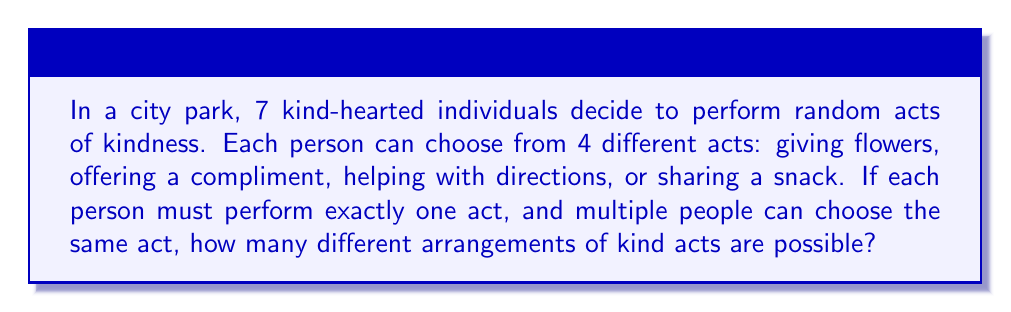Solve this math problem. Let's approach this step-by-step:

1) We have 7 people, each of whom needs to choose 1 act out of 4 possible acts.

2) For each person, there are 4 choices, and their choice is independent of the others.

3) This scenario fits the multiplication principle of counting.

4) According to this principle, if we have a sequence of $n$ independent choices, where the $i$-th choice has $k_i$ options, the total number of possible outcomes is the product of the number of options for each choice.

5) In this case, we have 7 independent choices (one for each person), and each choice has 4 options.

6) Therefore, the total number of possible arrangements is:

   $$ 4 \times 4 \times 4 \times 4 \times 4 \times 4 \times 4 = 4^7 $$

7) We can calculate this:

   $$ 4^7 = 16,384 $$

Thus, there are 16,384 different possible arrangements of kind acts.
Answer: $4^7 = 16,384$ 